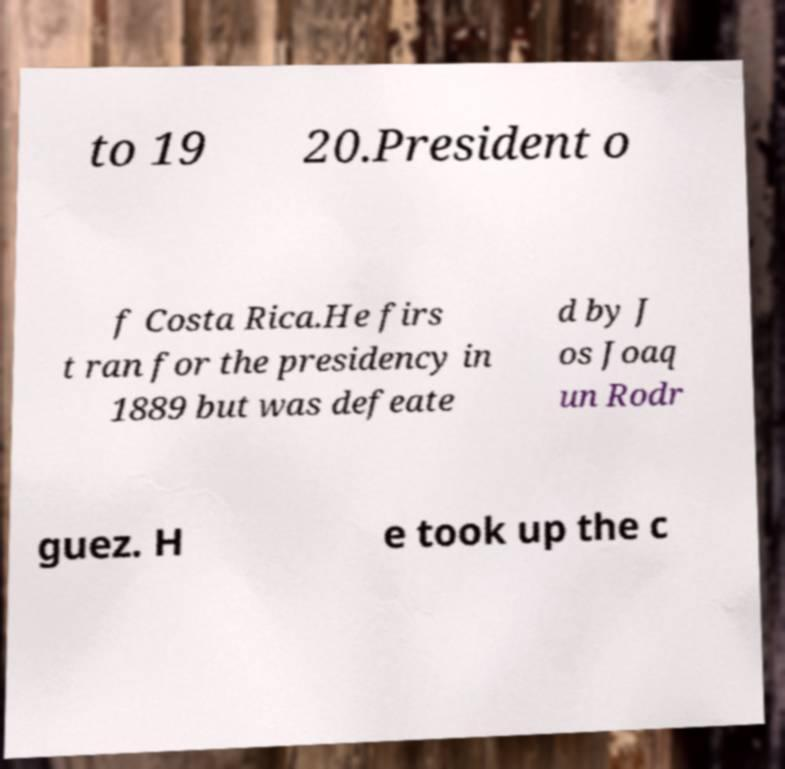Can you accurately transcribe the text from the provided image for me? to 19 20.President o f Costa Rica.He firs t ran for the presidency in 1889 but was defeate d by J os Joaq un Rodr guez. H e took up the c 